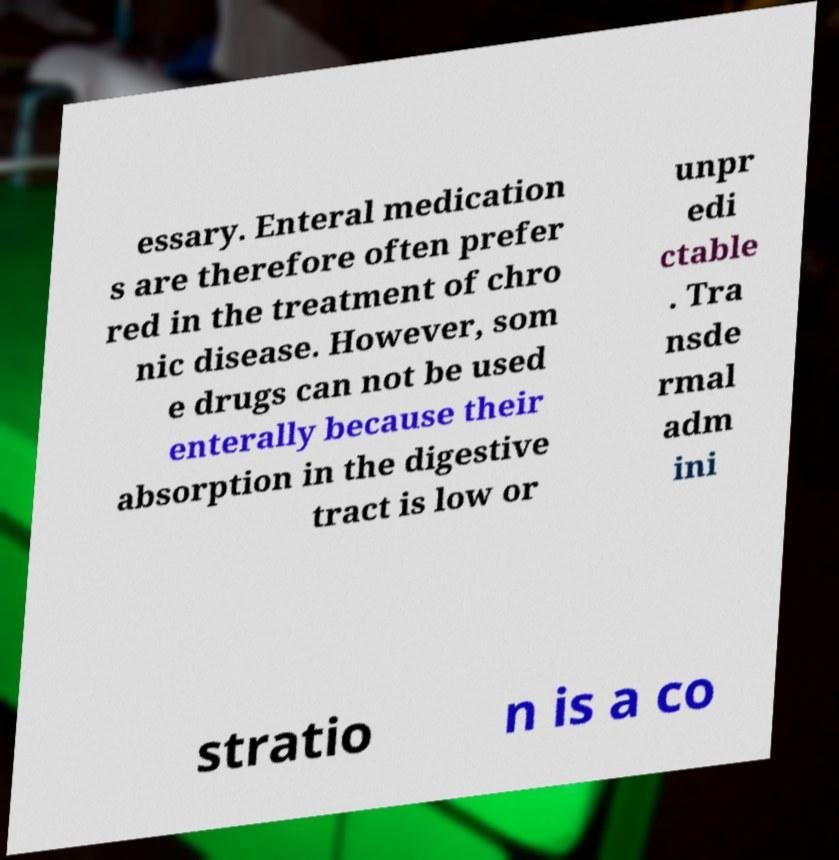There's text embedded in this image that I need extracted. Can you transcribe it verbatim? essary. Enteral medication s are therefore often prefer red in the treatment of chro nic disease. However, som e drugs can not be used enterally because their absorption in the digestive tract is low or unpr edi ctable . Tra nsde rmal adm ini stratio n is a co 